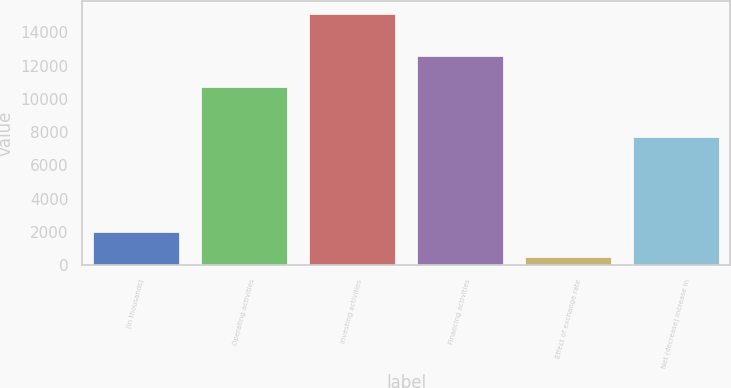<chart> <loc_0><loc_0><loc_500><loc_500><bar_chart><fcel>(In thousands)<fcel>Operating activities<fcel>Investing activities<fcel>Financing activities<fcel>Effect of exchange rate<fcel>Net (decrease) increase in<nl><fcel>2006<fcel>10701<fcel>15115<fcel>12579<fcel>487<fcel>7678<nl></chart> 